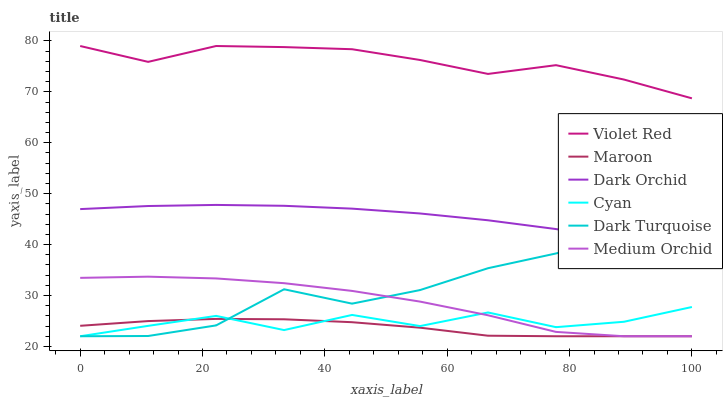Does Maroon have the minimum area under the curve?
Answer yes or no. Yes. Does Violet Red have the maximum area under the curve?
Answer yes or no. Yes. Does Dark Turquoise have the minimum area under the curve?
Answer yes or no. No. Does Dark Turquoise have the maximum area under the curve?
Answer yes or no. No. Is Dark Orchid the smoothest?
Answer yes or no. Yes. Is Dark Turquoise the roughest?
Answer yes or no. Yes. Is Medium Orchid the smoothest?
Answer yes or no. No. Is Medium Orchid the roughest?
Answer yes or no. No. Does Dark Turquoise have the lowest value?
Answer yes or no. Yes. Does Dark Orchid have the lowest value?
Answer yes or no. No. Does Violet Red have the highest value?
Answer yes or no. Yes. Does Dark Turquoise have the highest value?
Answer yes or no. No. Is Cyan less than Dark Orchid?
Answer yes or no. Yes. Is Violet Red greater than Dark Turquoise?
Answer yes or no. Yes. Does Medium Orchid intersect Dark Turquoise?
Answer yes or no. Yes. Is Medium Orchid less than Dark Turquoise?
Answer yes or no. No. Is Medium Orchid greater than Dark Turquoise?
Answer yes or no. No. Does Cyan intersect Dark Orchid?
Answer yes or no. No. 